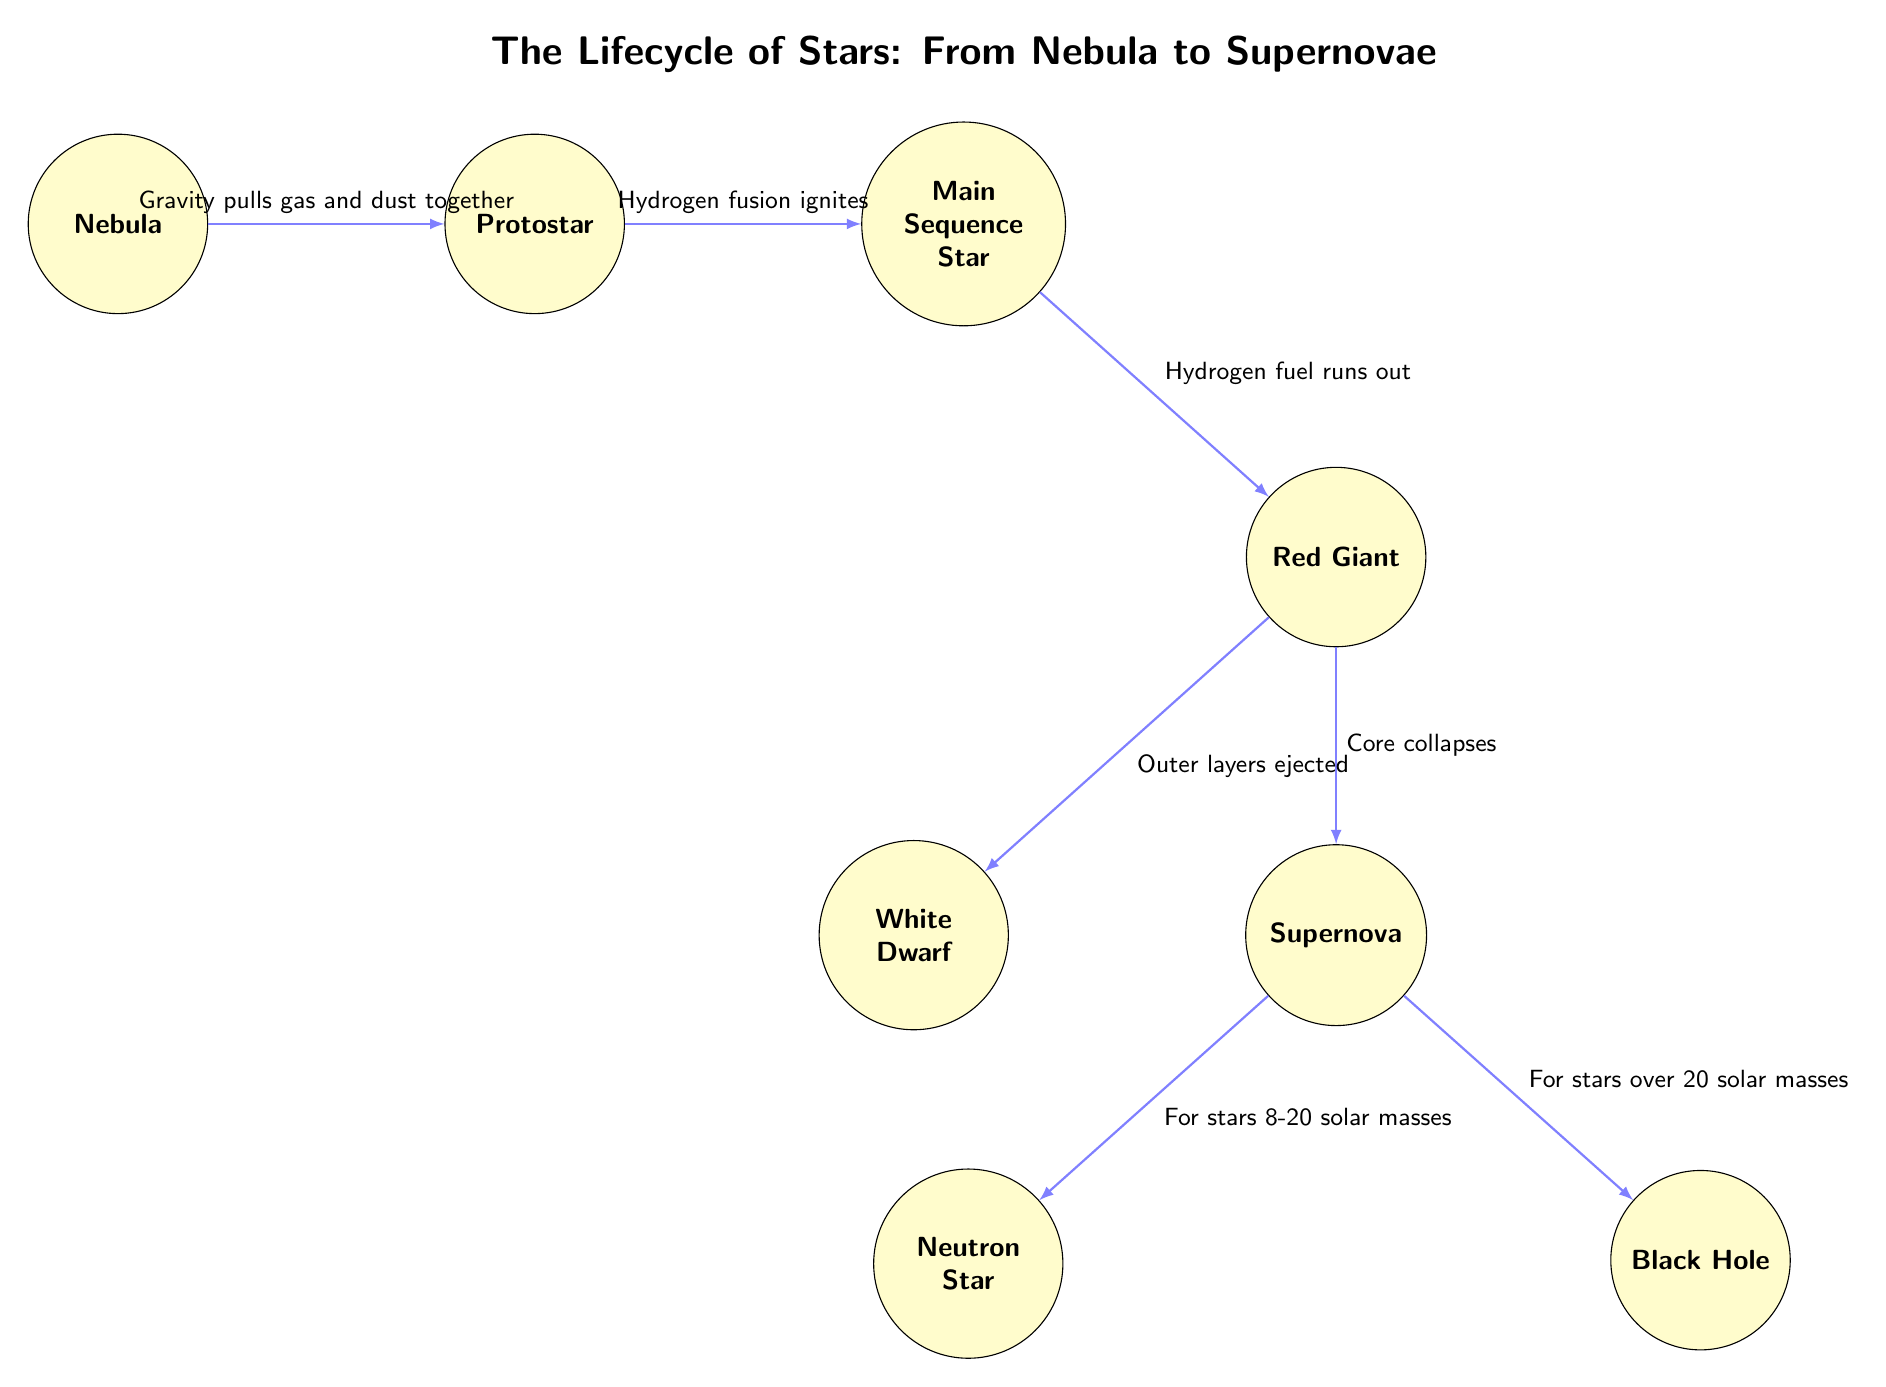What is the first stage of the star lifecycle shown in the diagram? The diagram starts with the node labeled "Nebula," indicating it is the first stage of the star lifecycle.
Answer: Nebula How many main stages of star lifecycle are depicted in the diagram? The diagram displays a total of seven nodes, which represent distinct stages of the star lifecycle, including the Nebula, Protostar, Main Sequence Star, Red Giant, Supernova, White Dwarf, Neutron Star, and Black Hole.
Answer: Seven What happens after the Main Sequence Star phase? The flow from the Main Sequence Star node points to the Red Giant node, indicating that the next phase after the Main Sequence Star is the Red Giant.
Answer: Red Giant Which stages lead to a Supernova? The diagram shows that the Red Giant stage leads to the Supernova stage, which implies a transition through the Red Giant before the Supernova occurs.
Answer: Red Giant What indicates the transition from Protostar to Main Sequence Star? The arrow from Protostar to Main Sequence Star is labeled "Hydrogen fusion ignites," indicating what marks the transition between these two stages.
Answer: Hydrogen fusion ignites What is the fate of stars over 20 solar masses according to the diagram? The diagram indicates that stars with more than 20 solar masses will result in a Black Hole after the Supernova event, as shown by the arrow directed towards the Black Hole node.
Answer: Black Hole Which stage is connected to the White Dwarf? The Red Giant stage is connected to the White Dwarf through the label "Outer layers ejected," indicating the relationship and pathway to become a White Dwarf.
Answer: Red Giant What causes the Core to collapse before a Supernova? According to the diagram, the reason for Core collapse before a Supernova is due to the Red Giant stage, as indicated by the flow pointing to the Supernova labeled "Core collapses."
Answer: Core collapses 